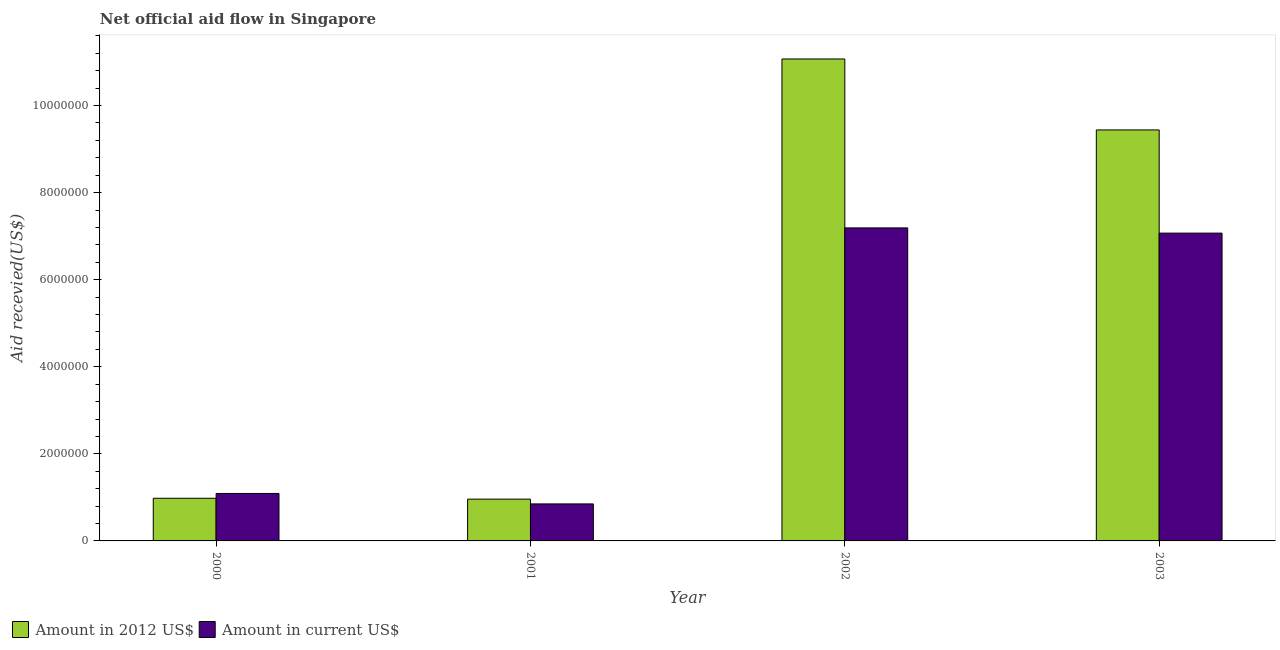How many different coloured bars are there?
Provide a short and direct response. 2. Are the number of bars on each tick of the X-axis equal?
Your answer should be compact. Yes. How many bars are there on the 1st tick from the left?
Your answer should be compact. 2. How many bars are there on the 3rd tick from the right?
Keep it short and to the point. 2. What is the label of the 4th group of bars from the left?
Provide a succinct answer. 2003. In how many cases, is the number of bars for a given year not equal to the number of legend labels?
Provide a succinct answer. 0. What is the amount of aid received(expressed in 2012 us$) in 2000?
Ensure brevity in your answer.  9.80e+05. Across all years, what is the maximum amount of aid received(expressed in 2012 us$)?
Provide a succinct answer. 1.11e+07. Across all years, what is the minimum amount of aid received(expressed in 2012 us$)?
Keep it short and to the point. 9.60e+05. What is the total amount of aid received(expressed in 2012 us$) in the graph?
Offer a terse response. 2.24e+07. What is the difference between the amount of aid received(expressed in us$) in 2000 and that in 2002?
Keep it short and to the point. -6.10e+06. What is the difference between the amount of aid received(expressed in us$) in 2003 and the amount of aid received(expressed in 2012 us$) in 2002?
Your answer should be very brief. -1.20e+05. What is the average amount of aid received(expressed in 2012 us$) per year?
Provide a short and direct response. 5.61e+06. What is the ratio of the amount of aid received(expressed in 2012 us$) in 2000 to that in 2002?
Make the answer very short. 0.09. What is the difference between the highest and the second highest amount of aid received(expressed in 2012 us$)?
Offer a terse response. 1.63e+06. What is the difference between the highest and the lowest amount of aid received(expressed in us$)?
Offer a terse response. 6.34e+06. In how many years, is the amount of aid received(expressed in 2012 us$) greater than the average amount of aid received(expressed in 2012 us$) taken over all years?
Provide a succinct answer. 2. What does the 2nd bar from the left in 2000 represents?
Give a very brief answer. Amount in current US$. What does the 1st bar from the right in 2001 represents?
Offer a terse response. Amount in current US$. How many years are there in the graph?
Ensure brevity in your answer.  4. Does the graph contain any zero values?
Make the answer very short. No. Does the graph contain grids?
Offer a terse response. No. What is the title of the graph?
Keep it short and to the point. Net official aid flow in Singapore. What is the label or title of the X-axis?
Ensure brevity in your answer.  Year. What is the label or title of the Y-axis?
Your answer should be compact. Aid recevied(US$). What is the Aid recevied(US$) of Amount in 2012 US$ in 2000?
Provide a succinct answer. 9.80e+05. What is the Aid recevied(US$) in Amount in current US$ in 2000?
Your response must be concise. 1.09e+06. What is the Aid recevied(US$) of Amount in 2012 US$ in 2001?
Provide a short and direct response. 9.60e+05. What is the Aid recevied(US$) of Amount in current US$ in 2001?
Provide a short and direct response. 8.50e+05. What is the Aid recevied(US$) of Amount in 2012 US$ in 2002?
Ensure brevity in your answer.  1.11e+07. What is the Aid recevied(US$) of Amount in current US$ in 2002?
Your answer should be very brief. 7.19e+06. What is the Aid recevied(US$) in Amount in 2012 US$ in 2003?
Provide a short and direct response. 9.44e+06. What is the Aid recevied(US$) in Amount in current US$ in 2003?
Offer a terse response. 7.07e+06. Across all years, what is the maximum Aid recevied(US$) of Amount in 2012 US$?
Your response must be concise. 1.11e+07. Across all years, what is the maximum Aid recevied(US$) of Amount in current US$?
Keep it short and to the point. 7.19e+06. Across all years, what is the minimum Aid recevied(US$) of Amount in 2012 US$?
Ensure brevity in your answer.  9.60e+05. Across all years, what is the minimum Aid recevied(US$) of Amount in current US$?
Your response must be concise. 8.50e+05. What is the total Aid recevied(US$) in Amount in 2012 US$ in the graph?
Keep it short and to the point. 2.24e+07. What is the total Aid recevied(US$) in Amount in current US$ in the graph?
Offer a very short reply. 1.62e+07. What is the difference between the Aid recevied(US$) in Amount in 2012 US$ in 2000 and that in 2002?
Your answer should be very brief. -1.01e+07. What is the difference between the Aid recevied(US$) in Amount in current US$ in 2000 and that in 2002?
Ensure brevity in your answer.  -6.10e+06. What is the difference between the Aid recevied(US$) of Amount in 2012 US$ in 2000 and that in 2003?
Offer a terse response. -8.46e+06. What is the difference between the Aid recevied(US$) in Amount in current US$ in 2000 and that in 2003?
Your answer should be compact. -5.98e+06. What is the difference between the Aid recevied(US$) of Amount in 2012 US$ in 2001 and that in 2002?
Make the answer very short. -1.01e+07. What is the difference between the Aid recevied(US$) in Amount in current US$ in 2001 and that in 2002?
Keep it short and to the point. -6.34e+06. What is the difference between the Aid recevied(US$) of Amount in 2012 US$ in 2001 and that in 2003?
Provide a succinct answer. -8.48e+06. What is the difference between the Aid recevied(US$) in Amount in current US$ in 2001 and that in 2003?
Your answer should be compact. -6.22e+06. What is the difference between the Aid recevied(US$) in Amount in 2012 US$ in 2002 and that in 2003?
Your answer should be very brief. 1.63e+06. What is the difference between the Aid recevied(US$) in Amount in 2012 US$ in 2000 and the Aid recevied(US$) in Amount in current US$ in 2002?
Make the answer very short. -6.21e+06. What is the difference between the Aid recevied(US$) in Amount in 2012 US$ in 2000 and the Aid recevied(US$) in Amount in current US$ in 2003?
Offer a terse response. -6.09e+06. What is the difference between the Aid recevied(US$) in Amount in 2012 US$ in 2001 and the Aid recevied(US$) in Amount in current US$ in 2002?
Your answer should be compact. -6.23e+06. What is the difference between the Aid recevied(US$) of Amount in 2012 US$ in 2001 and the Aid recevied(US$) of Amount in current US$ in 2003?
Keep it short and to the point. -6.11e+06. What is the average Aid recevied(US$) of Amount in 2012 US$ per year?
Ensure brevity in your answer.  5.61e+06. What is the average Aid recevied(US$) in Amount in current US$ per year?
Keep it short and to the point. 4.05e+06. In the year 2000, what is the difference between the Aid recevied(US$) in Amount in 2012 US$ and Aid recevied(US$) in Amount in current US$?
Your answer should be compact. -1.10e+05. In the year 2002, what is the difference between the Aid recevied(US$) in Amount in 2012 US$ and Aid recevied(US$) in Amount in current US$?
Your answer should be very brief. 3.88e+06. In the year 2003, what is the difference between the Aid recevied(US$) in Amount in 2012 US$ and Aid recevied(US$) in Amount in current US$?
Provide a succinct answer. 2.37e+06. What is the ratio of the Aid recevied(US$) of Amount in 2012 US$ in 2000 to that in 2001?
Provide a short and direct response. 1.02. What is the ratio of the Aid recevied(US$) of Amount in current US$ in 2000 to that in 2001?
Give a very brief answer. 1.28. What is the ratio of the Aid recevied(US$) of Amount in 2012 US$ in 2000 to that in 2002?
Your answer should be compact. 0.09. What is the ratio of the Aid recevied(US$) in Amount in current US$ in 2000 to that in 2002?
Ensure brevity in your answer.  0.15. What is the ratio of the Aid recevied(US$) of Amount in 2012 US$ in 2000 to that in 2003?
Offer a very short reply. 0.1. What is the ratio of the Aid recevied(US$) of Amount in current US$ in 2000 to that in 2003?
Make the answer very short. 0.15. What is the ratio of the Aid recevied(US$) in Amount in 2012 US$ in 2001 to that in 2002?
Offer a terse response. 0.09. What is the ratio of the Aid recevied(US$) in Amount in current US$ in 2001 to that in 2002?
Ensure brevity in your answer.  0.12. What is the ratio of the Aid recevied(US$) of Amount in 2012 US$ in 2001 to that in 2003?
Ensure brevity in your answer.  0.1. What is the ratio of the Aid recevied(US$) of Amount in current US$ in 2001 to that in 2003?
Your answer should be very brief. 0.12. What is the ratio of the Aid recevied(US$) of Amount in 2012 US$ in 2002 to that in 2003?
Provide a short and direct response. 1.17. What is the ratio of the Aid recevied(US$) in Amount in current US$ in 2002 to that in 2003?
Your answer should be compact. 1.02. What is the difference between the highest and the second highest Aid recevied(US$) in Amount in 2012 US$?
Your response must be concise. 1.63e+06. What is the difference between the highest and the lowest Aid recevied(US$) in Amount in 2012 US$?
Your response must be concise. 1.01e+07. What is the difference between the highest and the lowest Aid recevied(US$) in Amount in current US$?
Offer a terse response. 6.34e+06. 